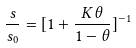Convert formula to latex. <formula><loc_0><loc_0><loc_500><loc_500>\frac { s } { s _ { 0 } } = [ 1 + \frac { K \theta } { 1 - \theta } ] ^ { - 1 }</formula> 